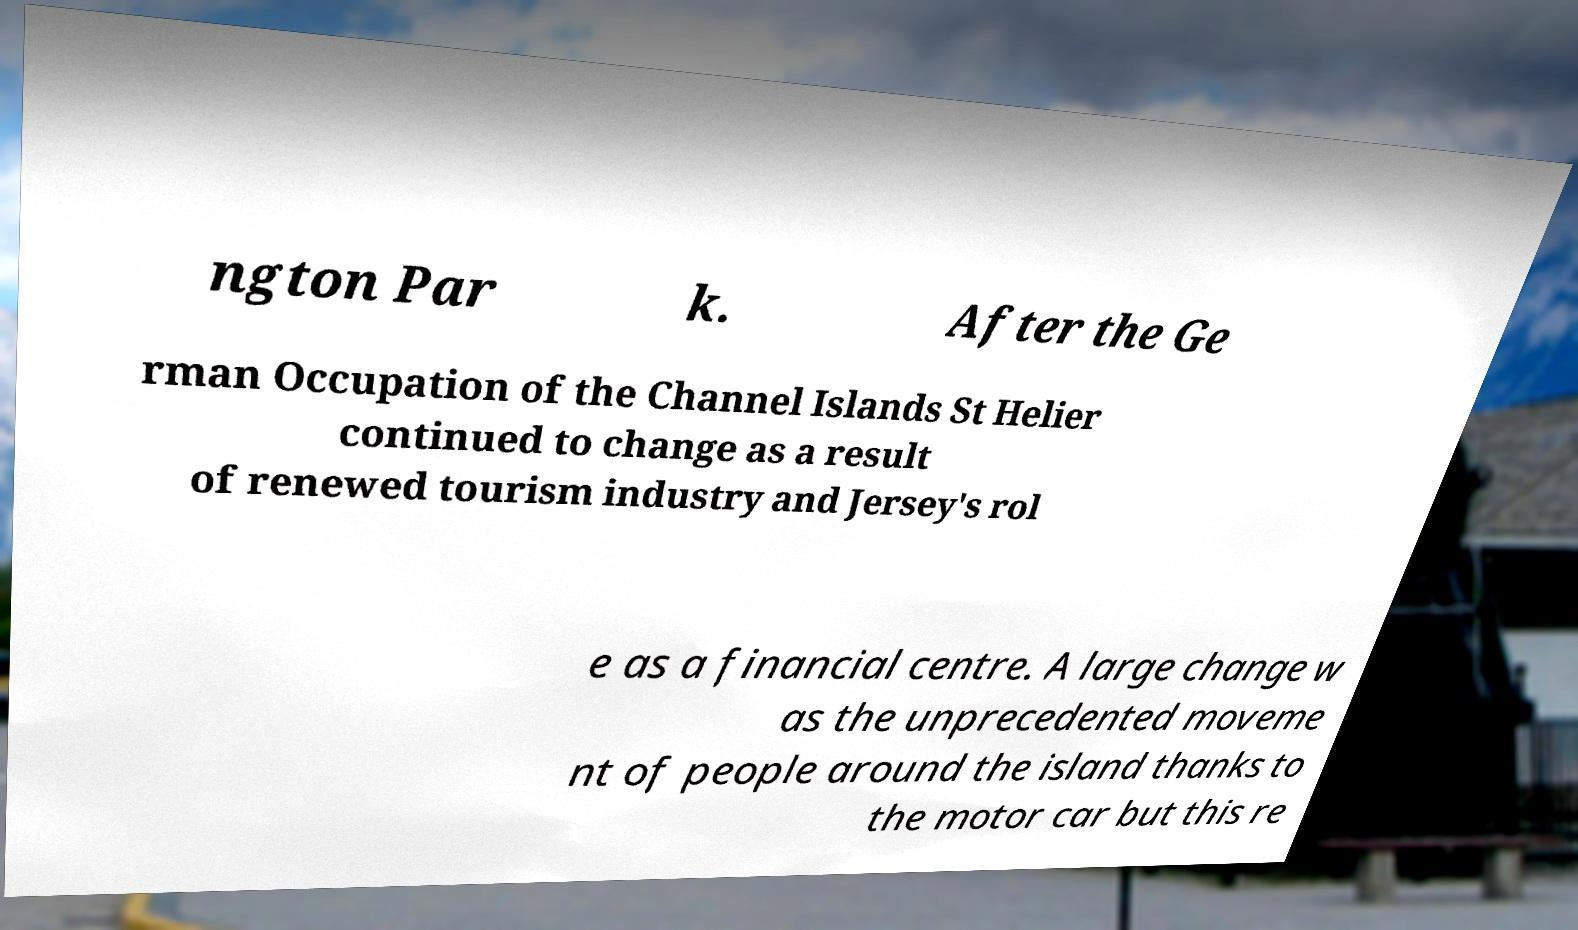Could you extract and type out the text from this image? ngton Par k. After the Ge rman Occupation of the Channel Islands St Helier continued to change as a result of renewed tourism industry and Jersey's rol e as a financial centre. A large change w as the unprecedented moveme nt of people around the island thanks to the motor car but this re 